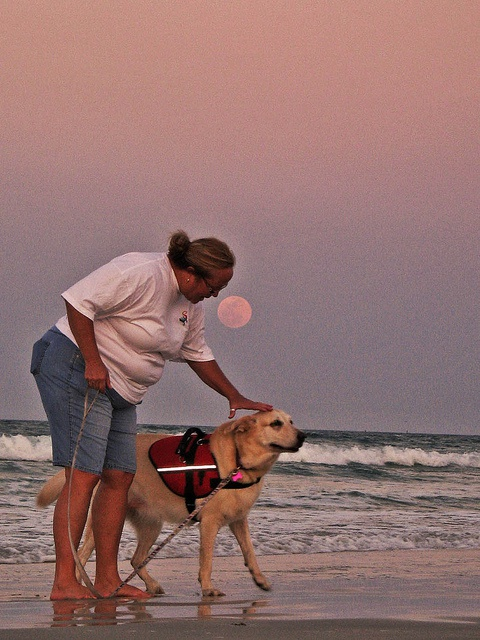Describe the objects in this image and their specific colors. I can see people in salmon, maroon, black, and gray tones and dog in salmon, brown, and maroon tones in this image. 